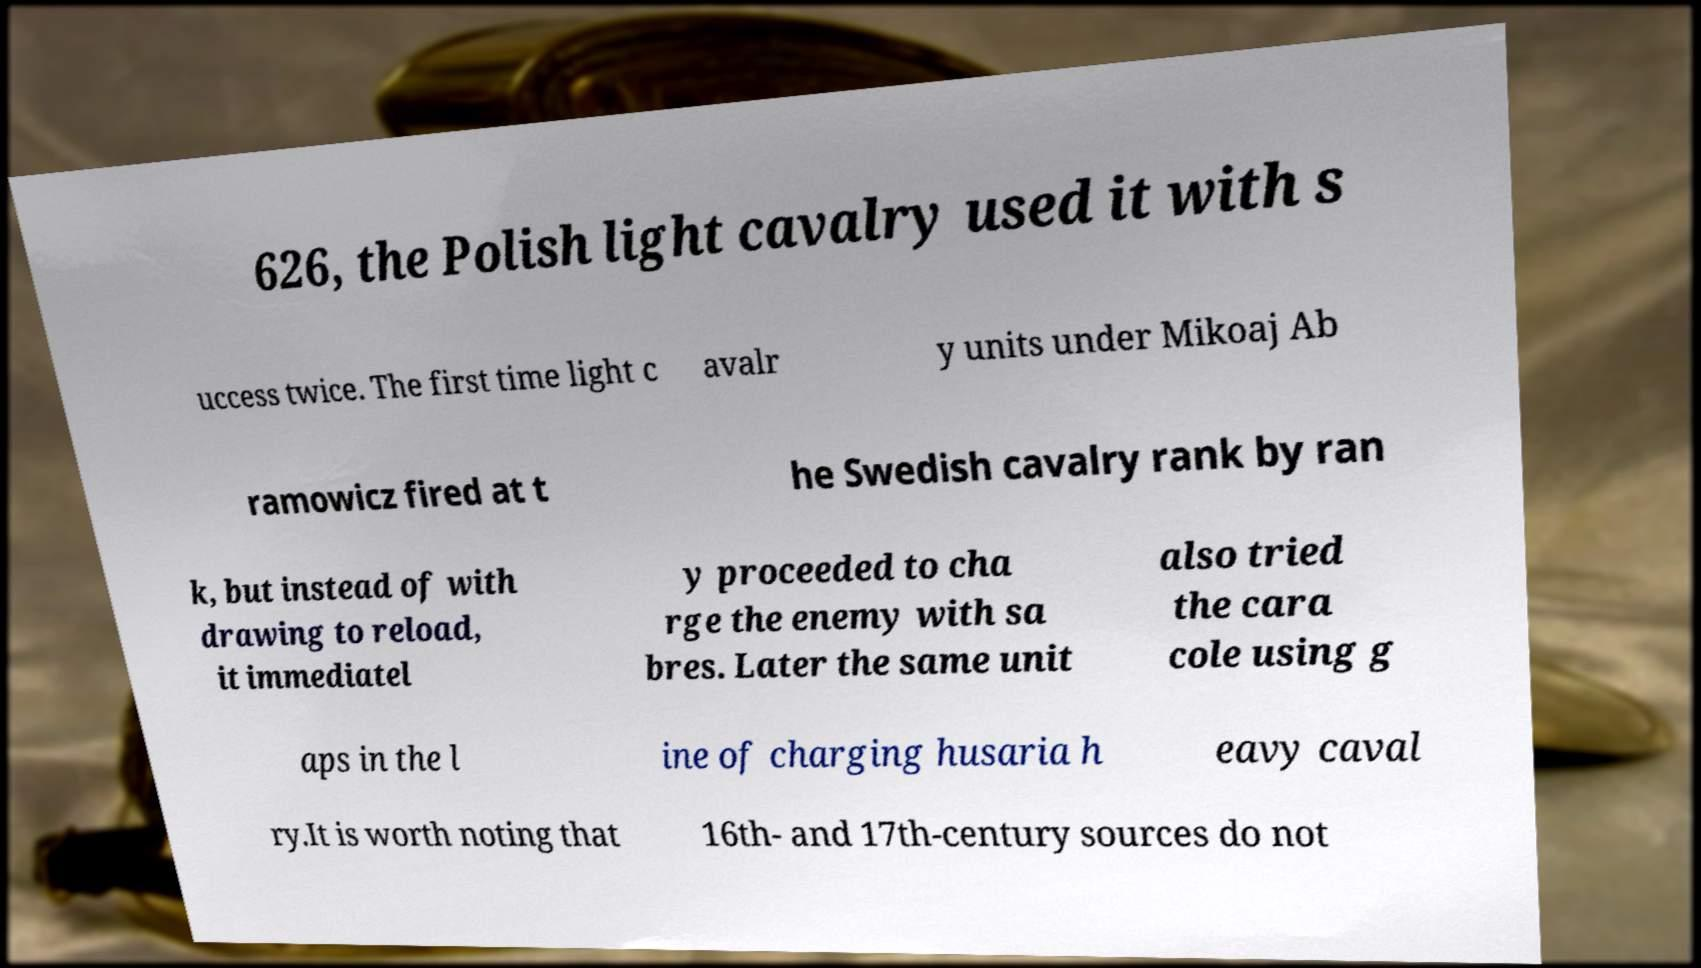Could you extract and type out the text from this image? 626, the Polish light cavalry used it with s uccess twice. The first time light c avalr y units under Mikoaj Ab ramowicz fired at t he Swedish cavalry rank by ran k, but instead of with drawing to reload, it immediatel y proceeded to cha rge the enemy with sa bres. Later the same unit also tried the cara cole using g aps in the l ine of charging husaria h eavy caval ry.It is worth noting that 16th- and 17th-century sources do not 